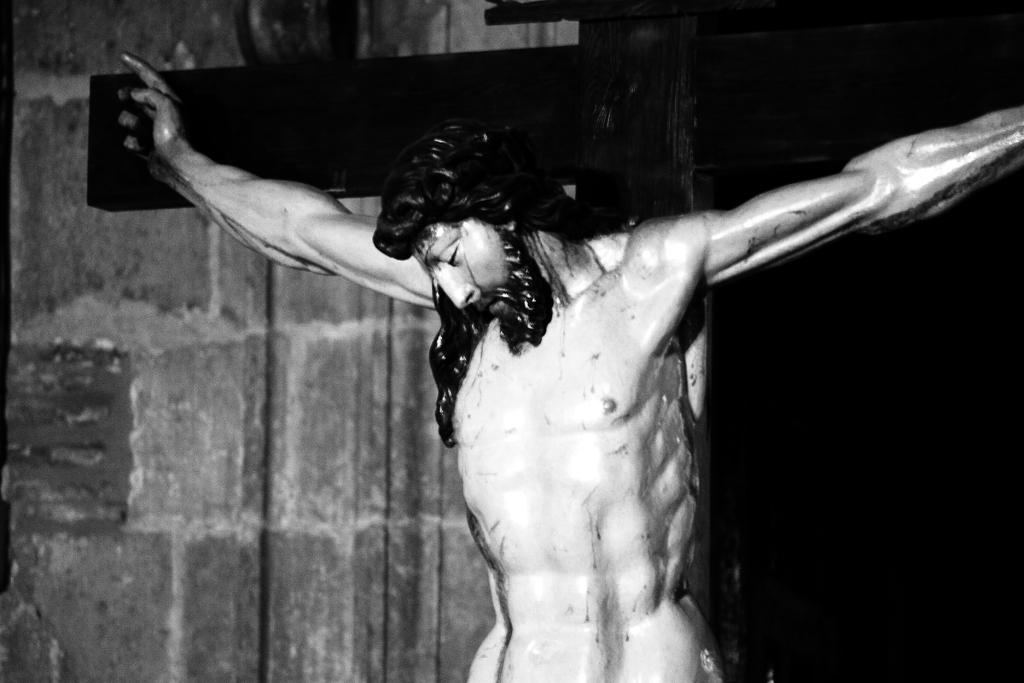What religious symbol is present in the image? There is a crucifix in the image. What can be seen in the background of the image? There is a wall in the background of the image. What hobbies does the crucifix enjoy in the image? The crucifix does not have hobbies, as it is a religious symbol and not a living being. 